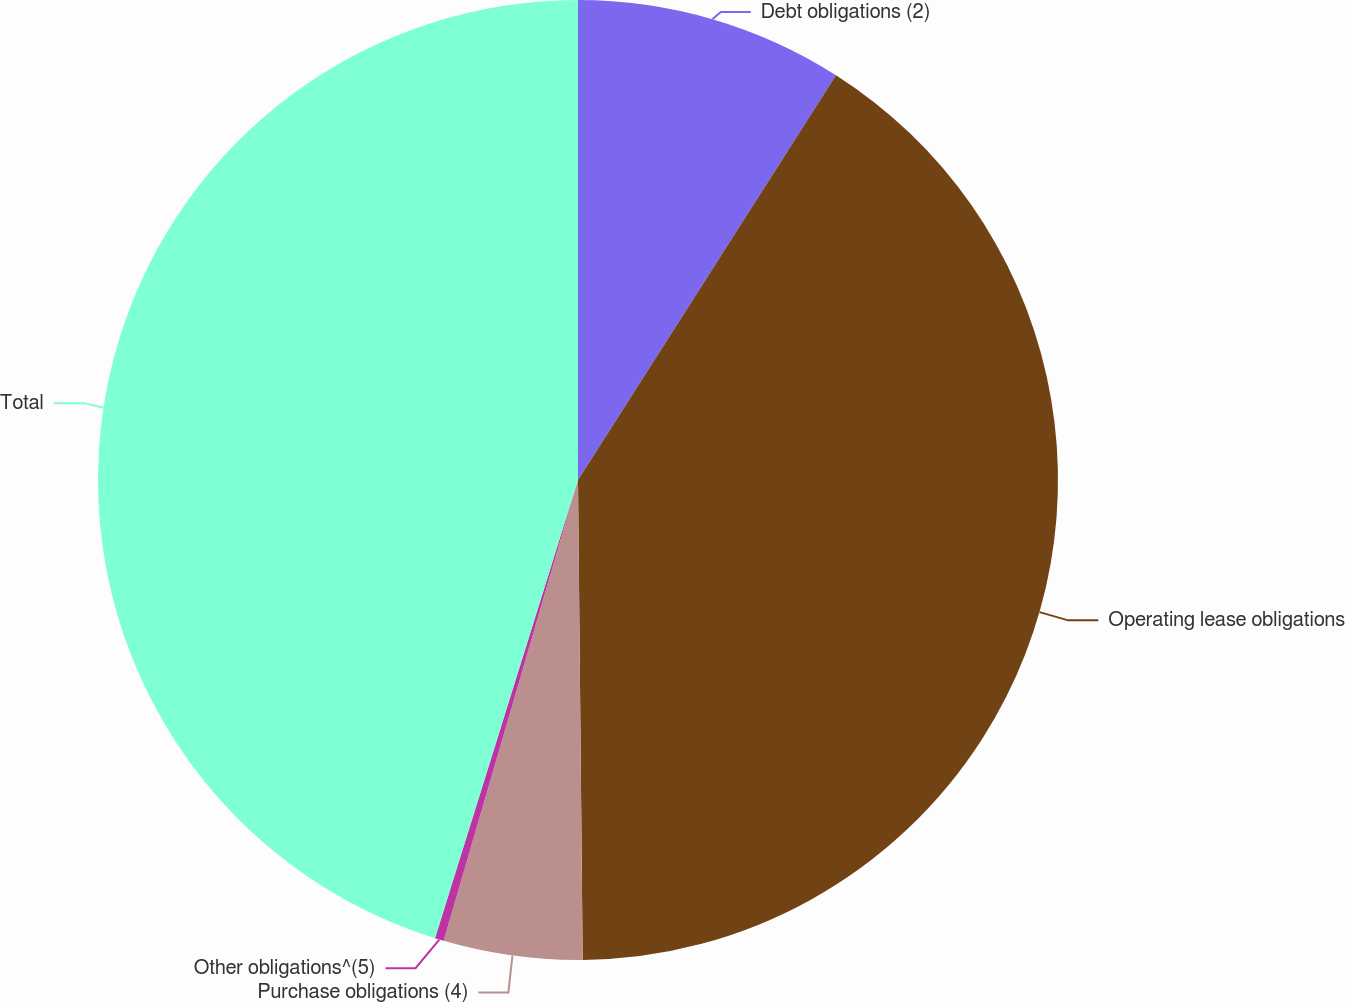Convert chart to OTSL. <chart><loc_0><loc_0><loc_500><loc_500><pie_chart><fcel>Debt obligations (2)<fcel>Operating lease obligations<fcel>Purchase obligations (4)<fcel>Other obligations^(5)<fcel>Total<nl><fcel>9.03%<fcel>40.81%<fcel>4.67%<fcel>0.3%<fcel>45.18%<nl></chart> 